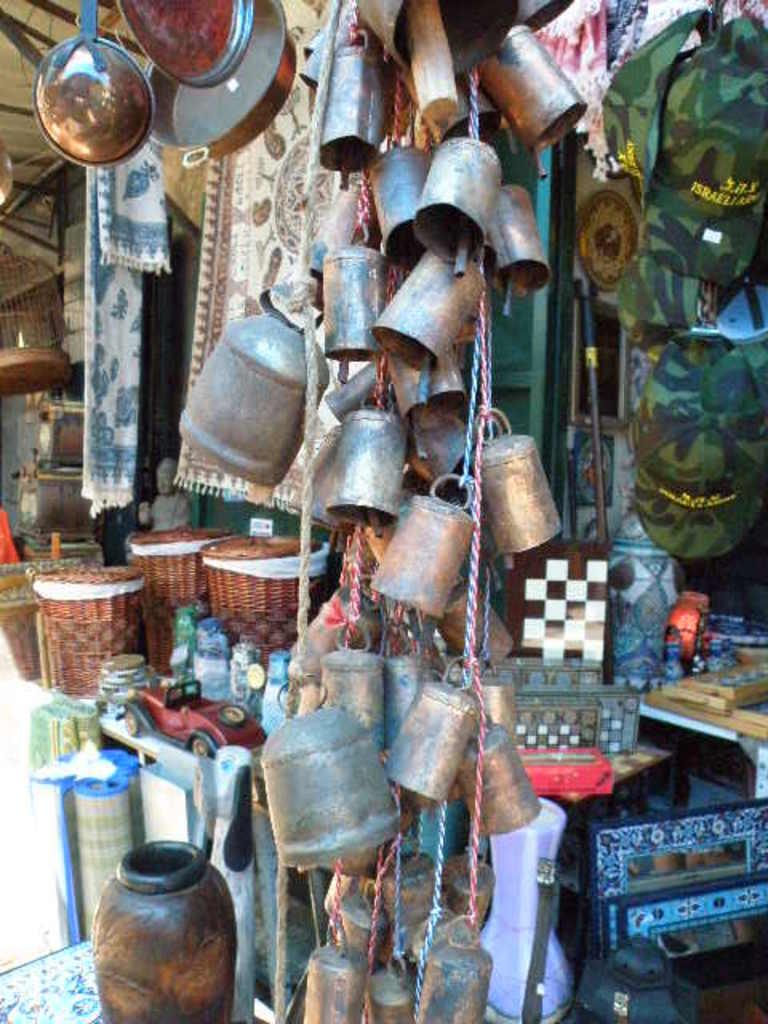What type of establishment is shown in the image? There is a store in the image. What are the vessels tied to in the image? The vessels are tied to a rope in the image. What can be seen to the right side of the image? There are caps to the right side of the image. Can you describe any other objects present in the image? There are many other objects in the image, but their specific details are not mentioned in the provided facts. How does the daughter contribute to the store's growth in the image? There is no mention of a daughter in the image or the provided facts, so we cannot answer this question. 